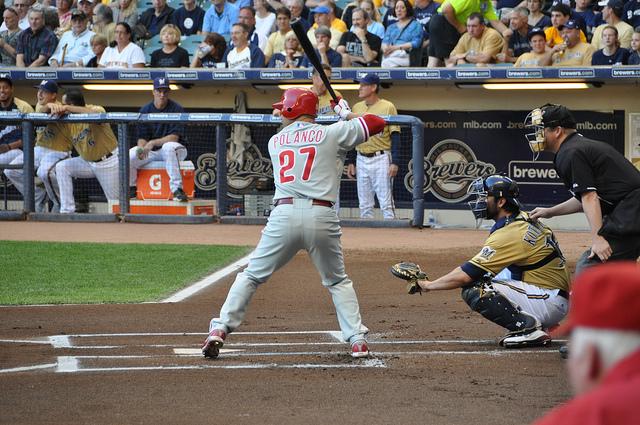What number is the batter?
Answer briefly. 27. What is the batter holding?
Write a very short answer. Bat. Is the baseball in the pitcher's mitt?
Be succinct. No. 